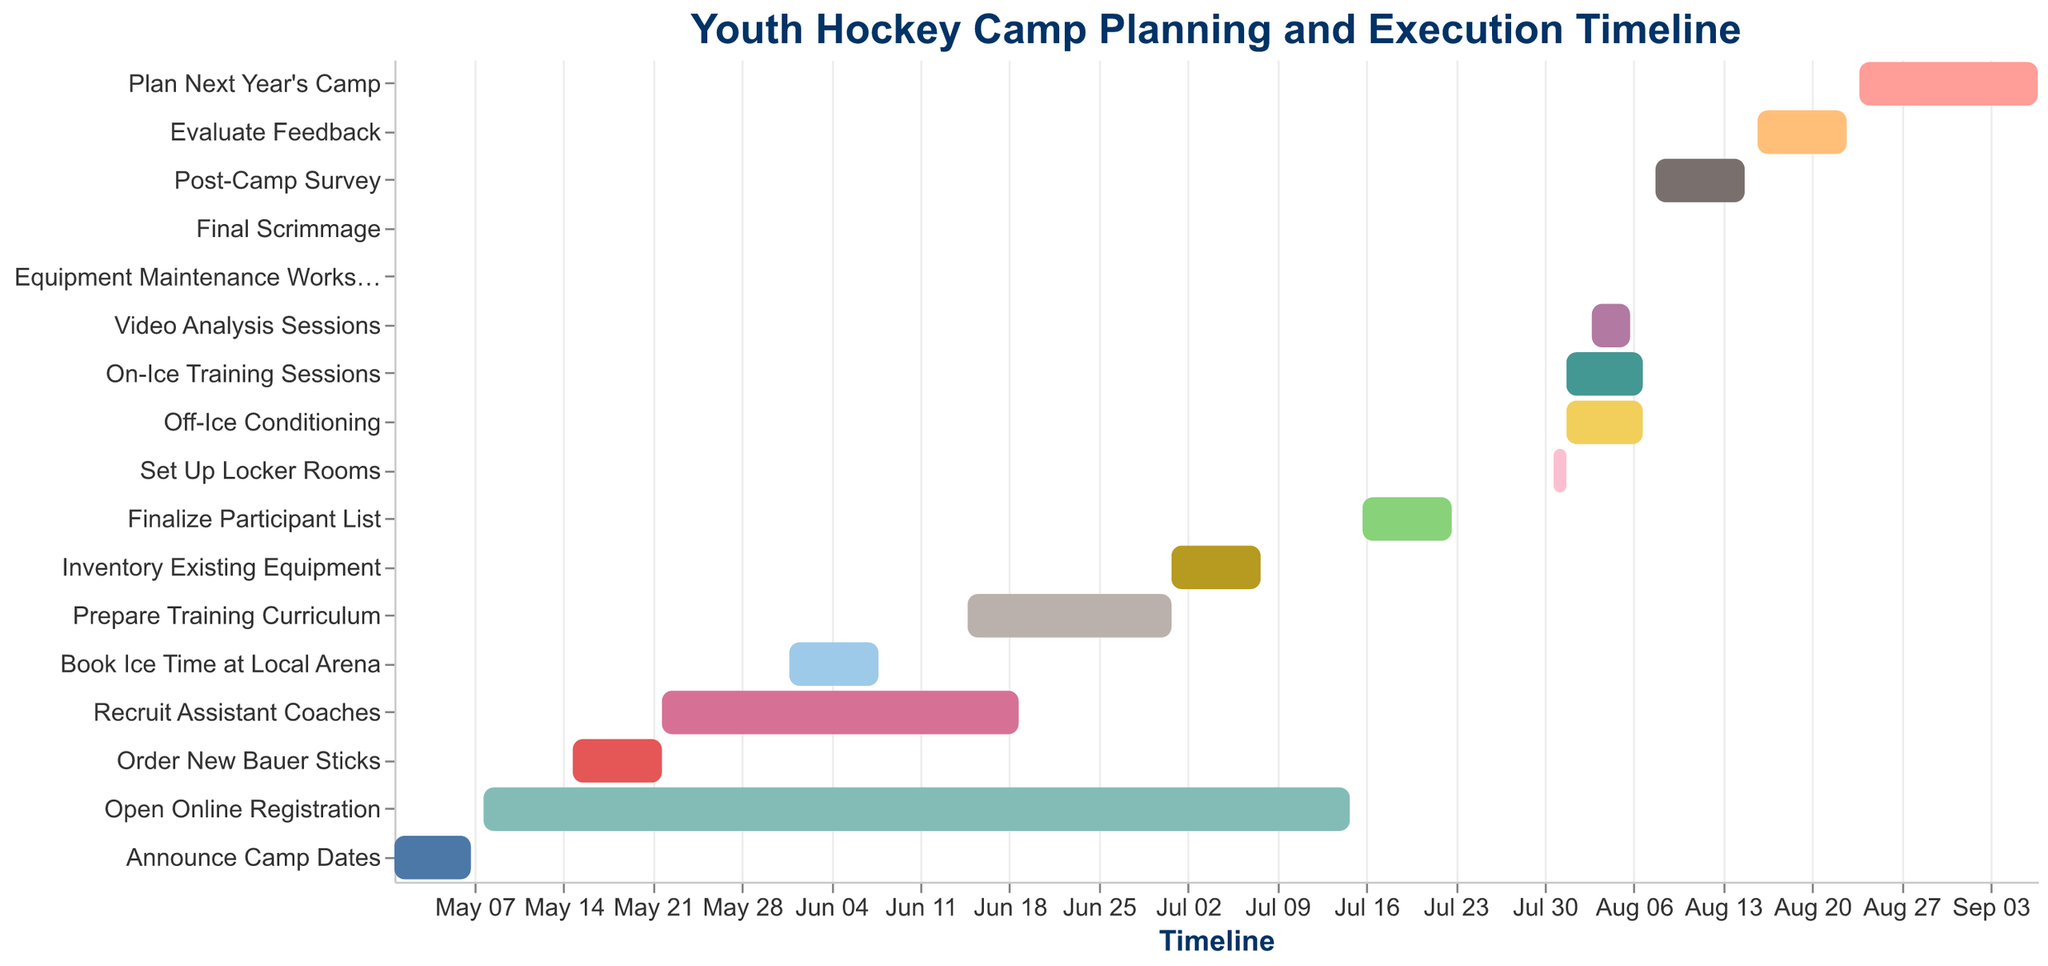How long is the "Open Online Registration" task? The "Open Online Registration" task starts on May 08, 2023, and ends on July 15, 2023. Firstly, convert these dates into the length in days: (May 08 to May 31) has 24 days, plus (June 01 to June 30) has 30 days, and (July 01 to July 15) has 15 days. Summing these up: 24 + 30 + 15 = 69 days
Answer: 69 days Which activity only lasts for one day? We need to look for activities where the start and end dates are the same. The "Equipment Maintenance Workshop" on August 05, 2023, and "Final Scrimmage" on August 07, 2023, both last for one day
Answer: "Equipment Maintenance Workshop" and "Final Scrimmage" What are the overlapping activities in the period from August 01, 2023, to August 07, 2023? Firstly, identify all activities within the mentioned period. The overlapping activities are "Set Up Locker Rooms" (July 31 - August 01), "On-Ice Training Sessions" (August 01 - August 07), "Off-Ice Conditioning" (August 01 - August 07), "Video Analysis Sessions" (August 03 - August 06), and "Equipment Maintenance Workshop" (August 05)
Answer: "Set Up Locker Rooms", "On-Ice Training Sessions", "Off-Ice Conditioning", "Video Analysis Sessions", "Equipment Maintenance Workshop" When does the task "Recruit Assistant Coaches" end relative to the start of "Prepare Training Curriculum"? "Recruit Assistant Coaches" ends on June 19, 2023, and "Prepare Training Curriculum" starts on June 15, 2023. Therefore, "Recruit Assistant Coaches" ends 4 days after "Prepare Training Curriculum" starts
Answer: 4 days after What is the total duration of the "Plan Next Year's Camp" task? The task "Plan Next Year's Camp" starts on August 24, 2023, and ends on September 07, 2023. Converting these dates into days: (August 24 to August 31) has 8 days, plus (September 01 to September 07) has 7 days. Summing these up: 8 + 7 = 15 days
Answer: 15 days Which is the longest single task in the timeline? By comparing the durations of all tasks, "Open Online Registration" lasts the longest, from May 08, 2023, to July 15, 2023, which is 69 days
Answer: "Open Online Registration" How many days after "Post-Camp Survey" does the "Evaluate Feedback" task start? "Post-Camp Survey" ends on August 15, 2023, and "Evaluate Feedback" begins on August 16, 2023. Therefore, "Evaluate Feedback" starts 1 day after "Post-Camp Survey" ends
Answer: 1 day What tasks overlap with "Video Analysis Sessions"? "Video Analysis Sessions" occurs from August 03, 2023, to August 06, 2023. The overlapping tasks are "On-Ice Training Sessions" and "Off-Ice Conditioning" which span from August 01, 2023, to August 07, 2023
Answer: "On-Ice Training Sessions" and "Off-Ice Conditioning" How many tasks are conducted entirely in August? Tasks completely within August are "Set Up Locker Rooms", "On-Ice Training Sessions", "Off-Ice Conditioning", "Video Analysis Sessions", "Equipment Maintenance Workshop", "Final Scrimmage", "Post-Camp Survey", and "Evaluate Feedback". Counting them gives us 8 tasks
Answer: 8 tasks 